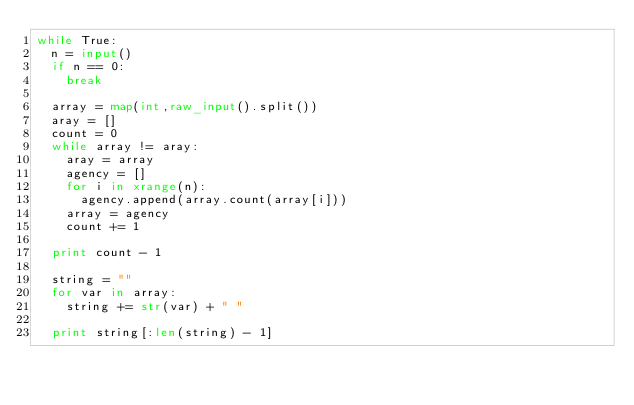Convert code to text. <code><loc_0><loc_0><loc_500><loc_500><_Python_>while True:
	n = input()
	if n == 0:
		break
	
	array = map(int,raw_input().split())
	aray = []
	count = 0
	while array != aray:
		aray = array
		agency = []
		for i in xrange(n):
			agency.append(array.count(array[i]))
		array = agency
		count += 1
		
	print count - 1
	
	string = ""
	for var in array:
		string += str(var) + " "
		
	print string[:len(string) - 1]</code> 